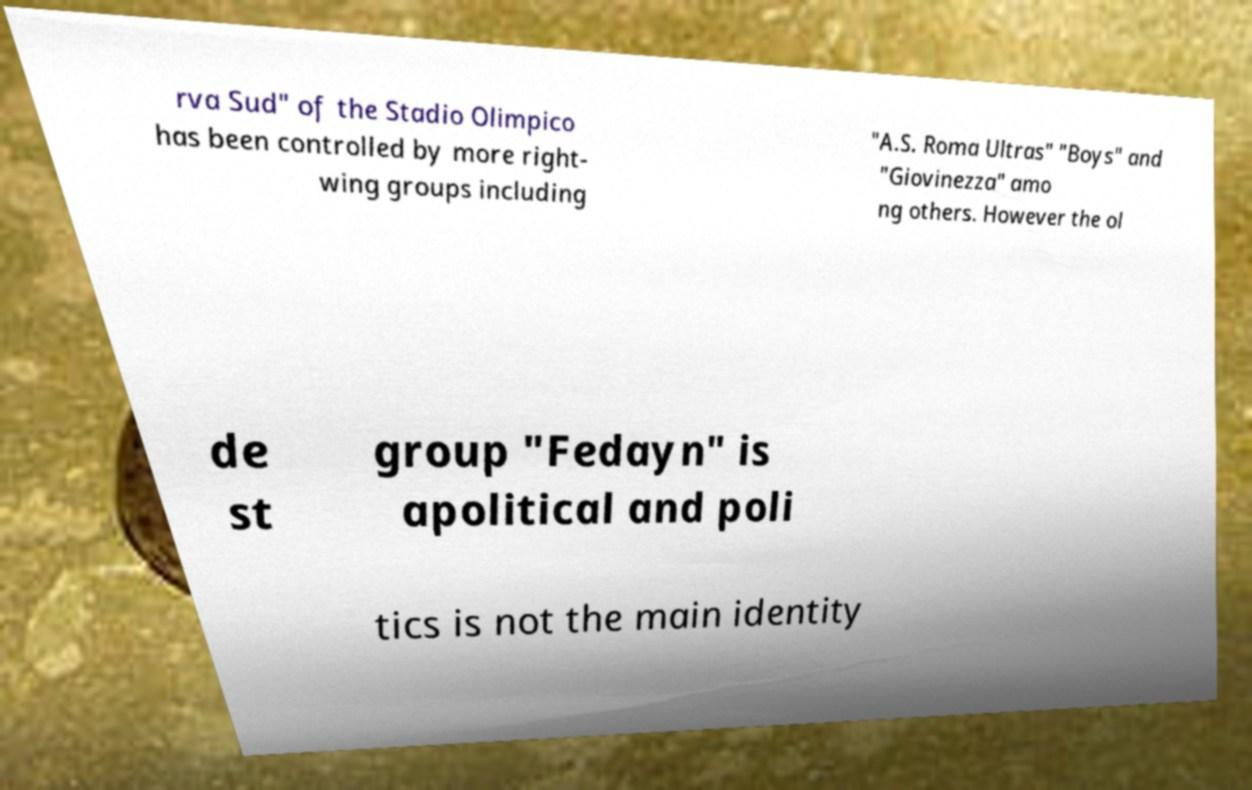Can you accurately transcribe the text from the provided image for me? rva Sud" of the Stadio Olimpico has been controlled by more right- wing groups including "A.S. Roma Ultras" "Boys" and "Giovinezza" amo ng others. However the ol de st group "Fedayn" is apolitical and poli tics is not the main identity 